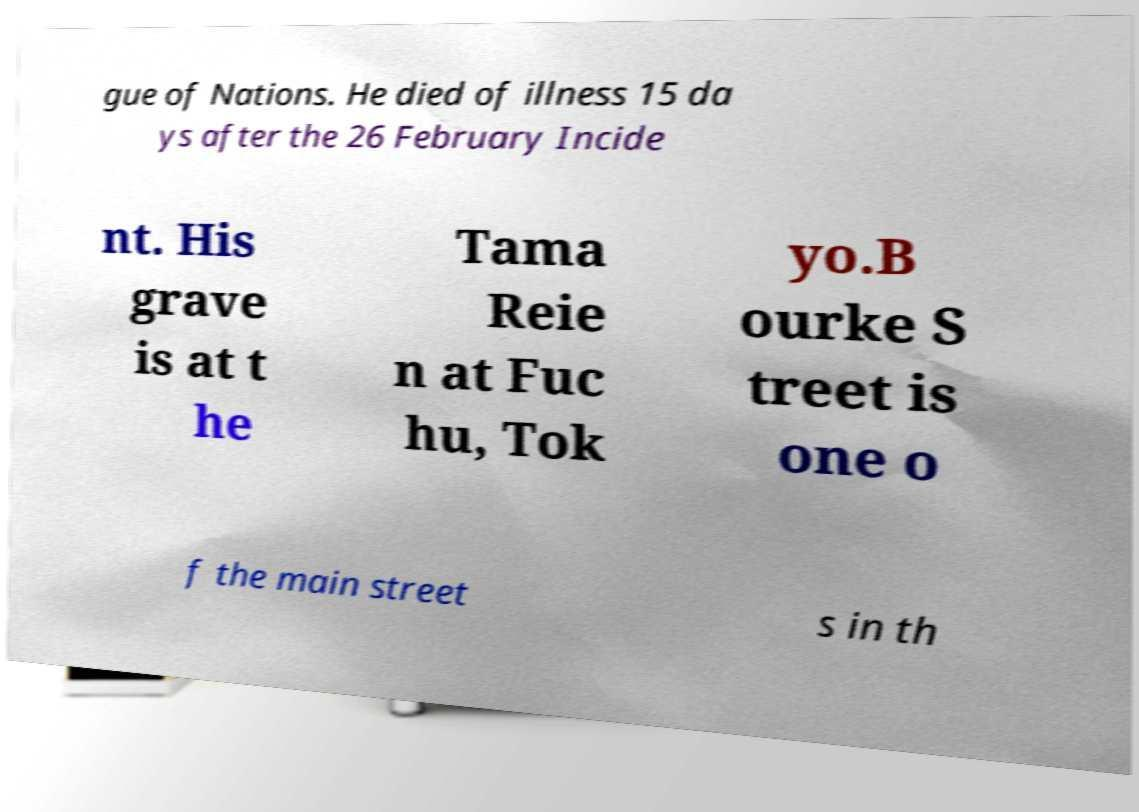For documentation purposes, I need the text within this image transcribed. Could you provide that? gue of Nations. He died of illness 15 da ys after the 26 February Incide nt. His grave is at t he Tama Reie n at Fuc hu, Tok yo.B ourke S treet is one o f the main street s in th 